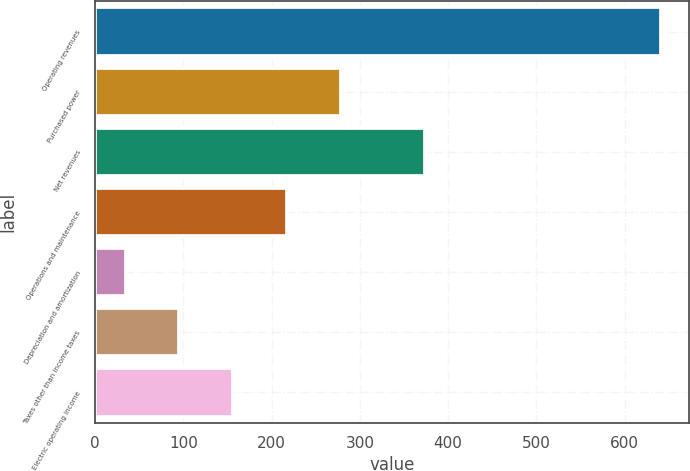Convert chart to OTSL. <chart><loc_0><loc_0><loc_500><loc_500><bar_chart><fcel>Operating revenues<fcel>Purchased power<fcel>Net revenues<fcel>Operations and maintenance<fcel>Depreciation and amortization<fcel>Taxes other than income taxes<fcel>Electric operating income<nl><fcel>641<fcel>278.6<fcel>374<fcel>218<fcel>35<fcel>95.6<fcel>156.2<nl></chart> 